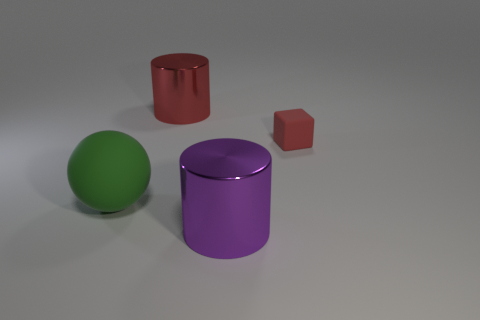There is a small red matte block; are there any red matte objects in front of it? no 